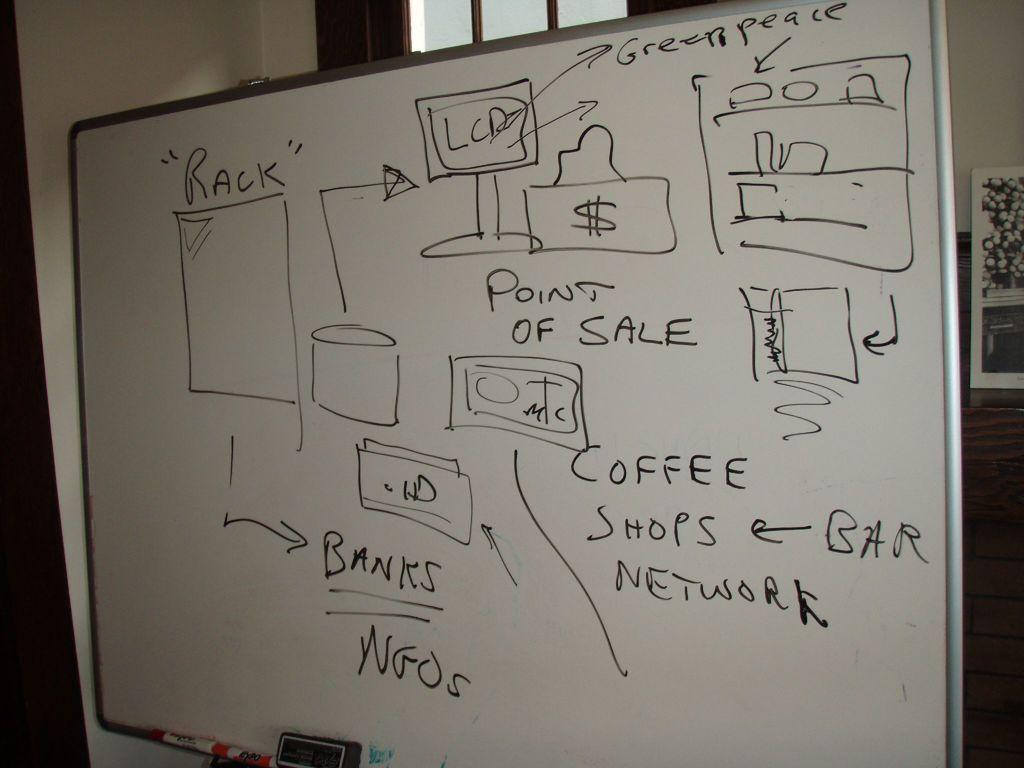What is on the board that is visible in the image? There is writing on the board in the image. What items are near the board that might be used for writing or drawing? There are markers near the board in the image. What object might be used for cleaning the board? There is a duster in the image. What can be seen in the background of the image? There is a wall in the background of the image. What type of code is visible on the right side of the image? There is a QR code on the right side of the image. What type of minister is depicted in the image? There is no minister present in the image. How does the sail move in the image? There is no sail present in the image. 